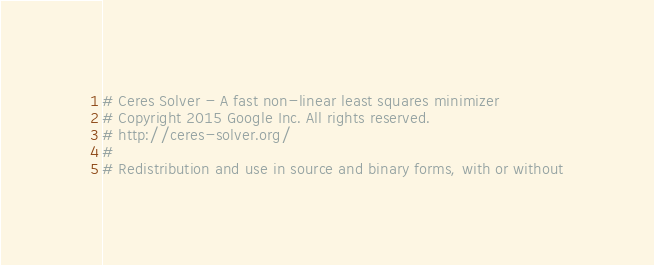Convert code to text. <code><loc_0><loc_0><loc_500><loc_500><_CMake_># Ceres Solver - A fast non-linear least squares minimizer
# Copyright 2015 Google Inc. All rights reserved.
# http://ceres-solver.org/
#
# Redistribution and use in source and binary forms, with or without</code> 